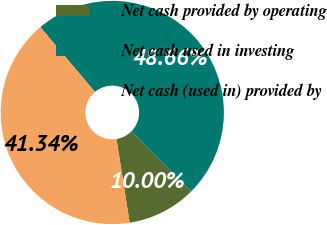Convert chart. <chart><loc_0><loc_0><loc_500><loc_500><pie_chart><fcel>Net cash provided by operating<fcel>Net cash used in investing<fcel>Net cash (used in) provided by<nl><fcel>10.0%<fcel>48.66%<fcel>41.34%<nl></chart> 